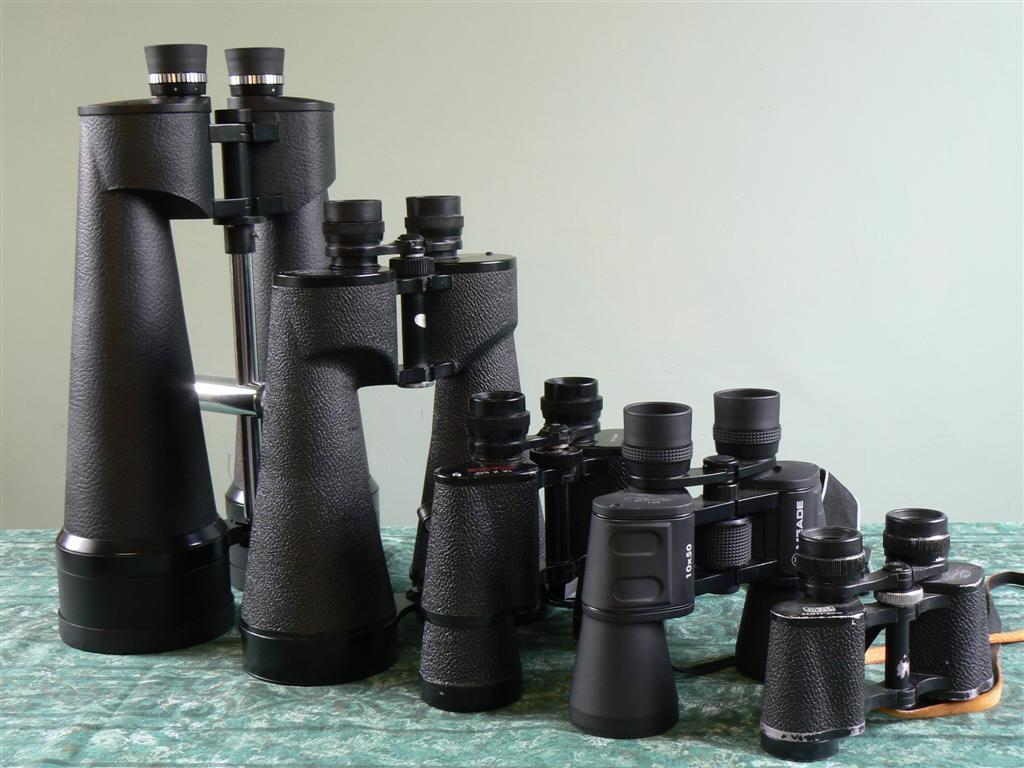What is the main object in the image? There are binoculars in the image. Where are the binoculars located? The binoculars are placed on a surface. What can be seen in the background of the image? There is a wall in the background of the image. What time of day is it in the image, and are there any pigs present? The time of day cannot be determined from the image, and there are no pigs present. 